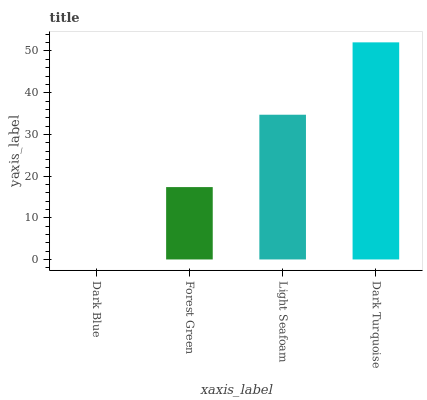Is Dark Blue the minimum?
Answer yes or no. Yes. Is Dark Turquoise the maximum?
Answer yes or no. Yes. Is Forest Green the minimum?
Answer yes or no. No. Is Forest Green the maximum?
Answer yes or no. No. Is Forest Green greater than Dark Blue?
Answer yes or no. Yes. Is Dark Blue less than Forest Green?
Answer yes or no. Yes. Is Dark Blue greater than Forest Green?
Answer yes or no. No. Is Forest Green less than Dark Blue?
Answer yes or no. No. Is Light Seafoam the high median?
Answer yes or no. Yes. Is Forest Green the low median?
Answer yes or no. Yes. Is Dark Turquoise the high median?
Answer yes or no. No. Is Light Seafoam the low median?
Answer yes or no. No. 